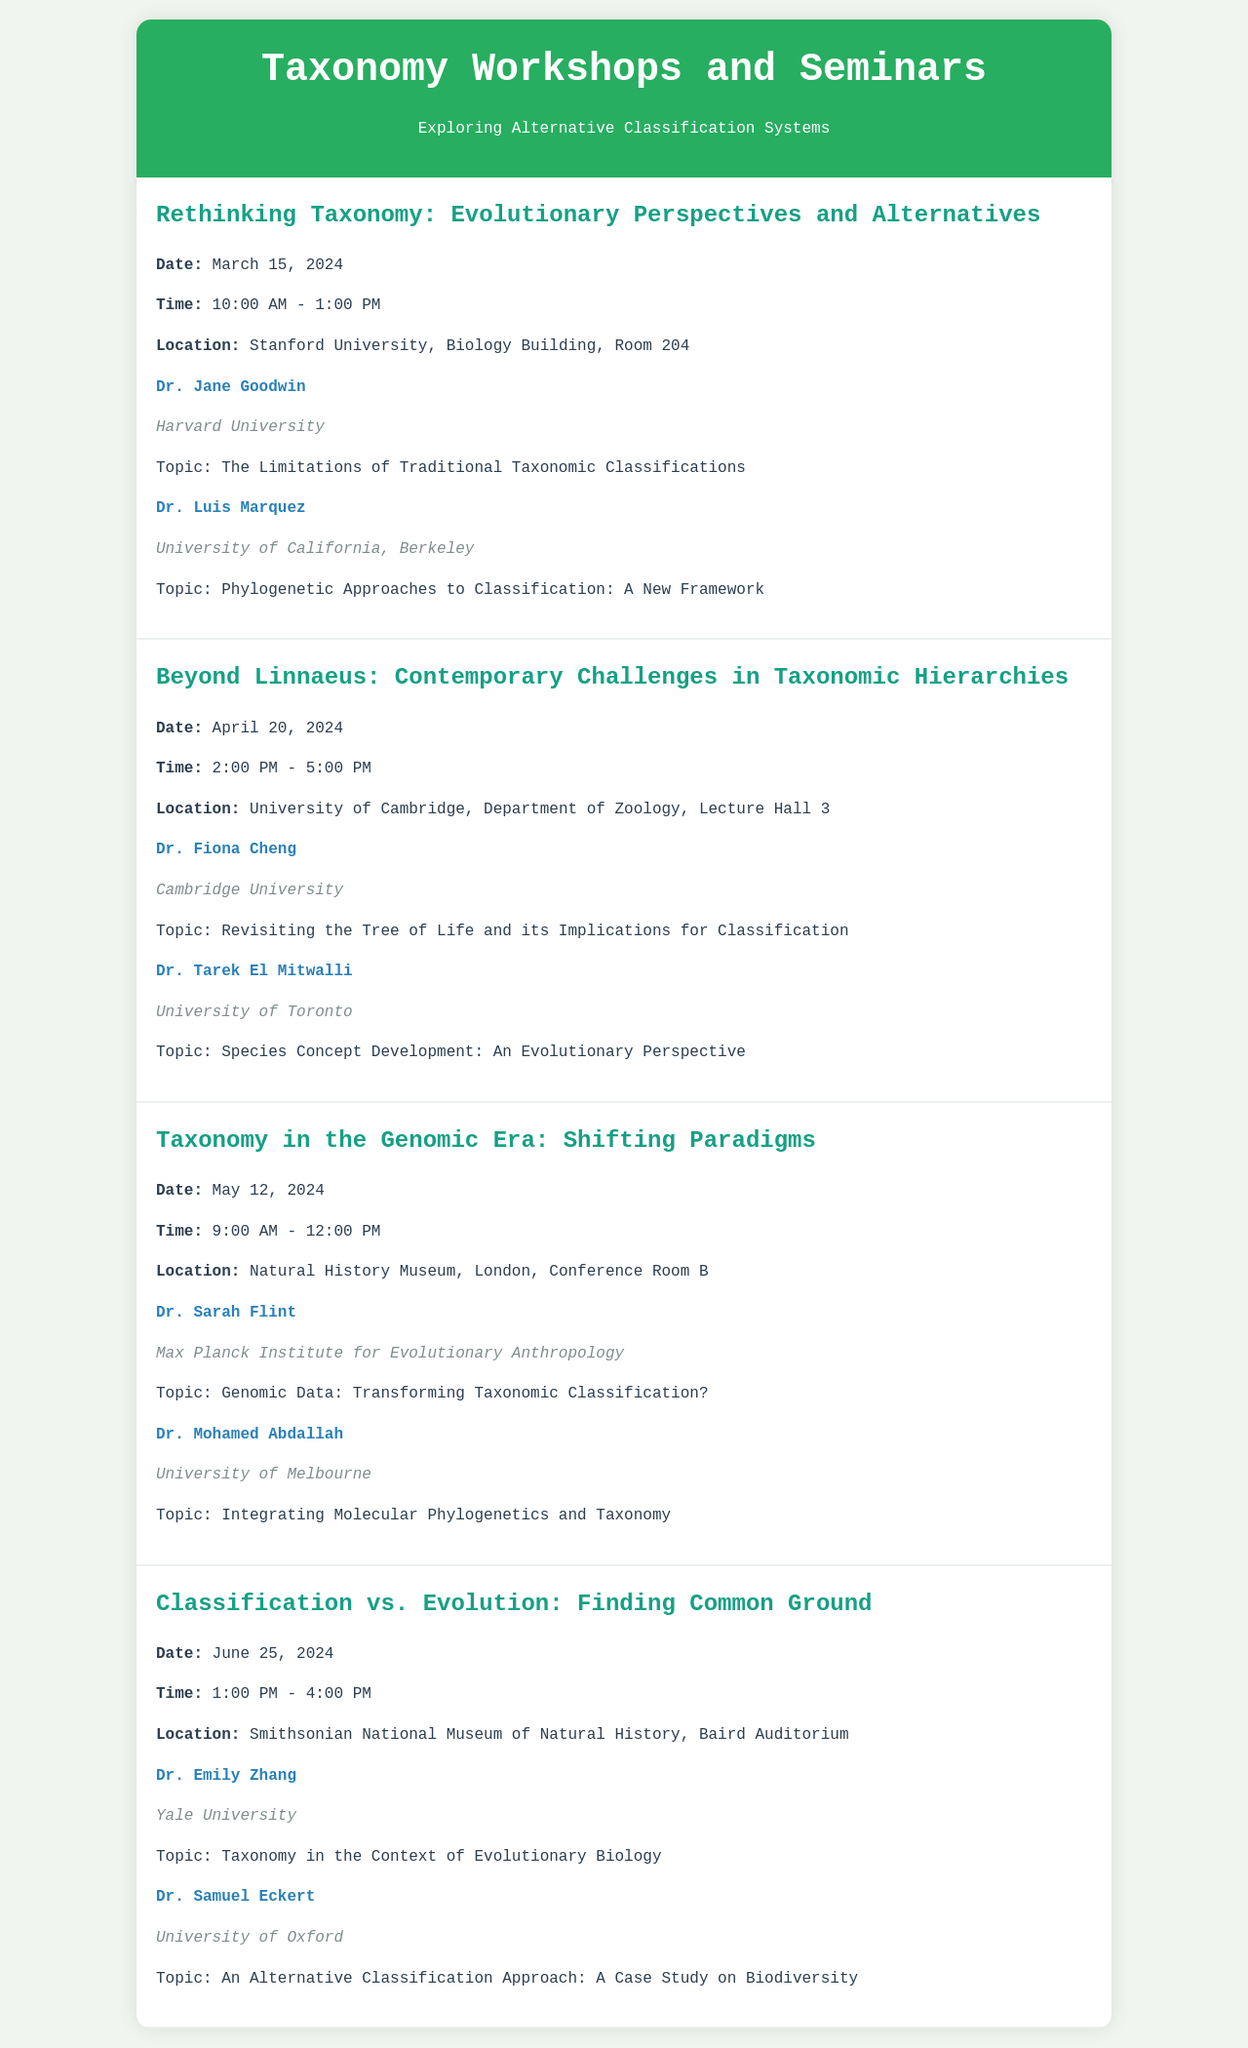What is the date of the workshop on Rethinking Taxonomy? The date for the workshop is explicitly stated in the document.
Answer: March 15, 2024 Who is the speaker from Harvard University? This information is found in the speaker section of the first workshop, indicating the affiliation and name of the speaker.
Answer: Dr. Jane Goodwin What is the location of the workshop titled Beyond Linnaeus? The location is specified as part of the workshop details.
Answer: University of Cambridge, Department of Zoology, Lecture Hall 3 How many speakers are featured in the Taxonomy in the Genomic Era workshop? The number of speakers can be counted from the provided workshop details.
Answer: 2 What is Dr. Emily Zhang's topic at the Classification vs. Evolution workshop? The topic is listed under the speaker information for Dr. Emily Zhang.
Answer: Taxonomy in the Context of Evolutionary Biology Which workshop discusses genomic data? This information requires knowledge of the content covered in the workshops.
Answer: Taxonomy in the Genomic Era: Shifting Paradigms What time does the workshop on June 25, 2024, begin? The starting time is clearly mentioned in the workshop schedule.
Answer: 1:00 PM Who is speaking about species concept development? This requires retrieval of the speaker name associated with the specified topic.
Answer: Dr. Tarek El Mitwalli 